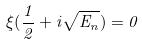Convert formula to latex. <formula><loc_0><loc_0><loc_500><loc_500>\xi ( \frac { 1 } { 2 } + i \sqrt { E _ { n } } ) = 0</formula> 